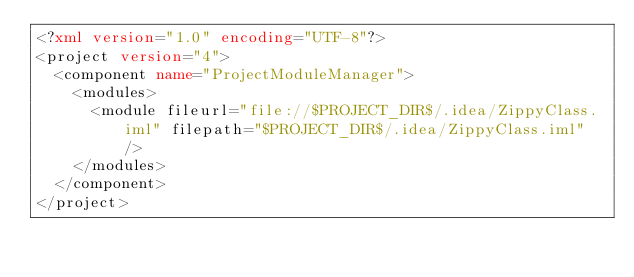<code> <loc_0><loc_0><loc_500><loc_500><_XML_><?xml version="1.0" encoding="UTF-8"?>
<project version="4">
  <component name="ProjectModuleManager">
    <modules>
      <module fileurl="file://$PROJECT_DIR$/.idea/ZippyClass.iml" filepath="$PROJECT_DIR$/.idea/ZippyClass.iml" />
    </modules>
  </component>
</project>

</code> 